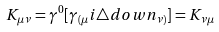Convert formula to latex. <formula><loc_0><loc_0><loc_500><loc_500>K _ { \mu \nu } = \gamma ^ { 0 } [ \gamma _ { ( \mu } i \triangle d o w n _ { \nu ) } ] = K _ { \nu \mu }</formula> 